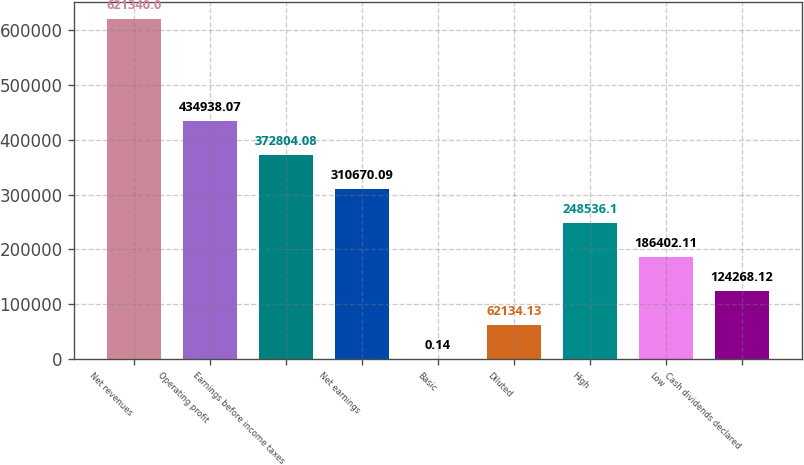Convert chart to OTSL. <chart><loc_0><loc_0><loc_500><loc_500><bar_chart><fcel>Net revenues<fcel>Operating profit<fcel>Earnings before income taxes<fcel>Net earnings<fcel>Basic<fcel>Diluted<fcel>High<fcel>Low<fcel>Cash dividends declared<nl><fcel>621340<fcel>434938<fcel>372804<fcel>310670<fcel>0.14<fcel>62134.1<fcel>248536<fcel>186402<fcel>124268<nl></chart> 